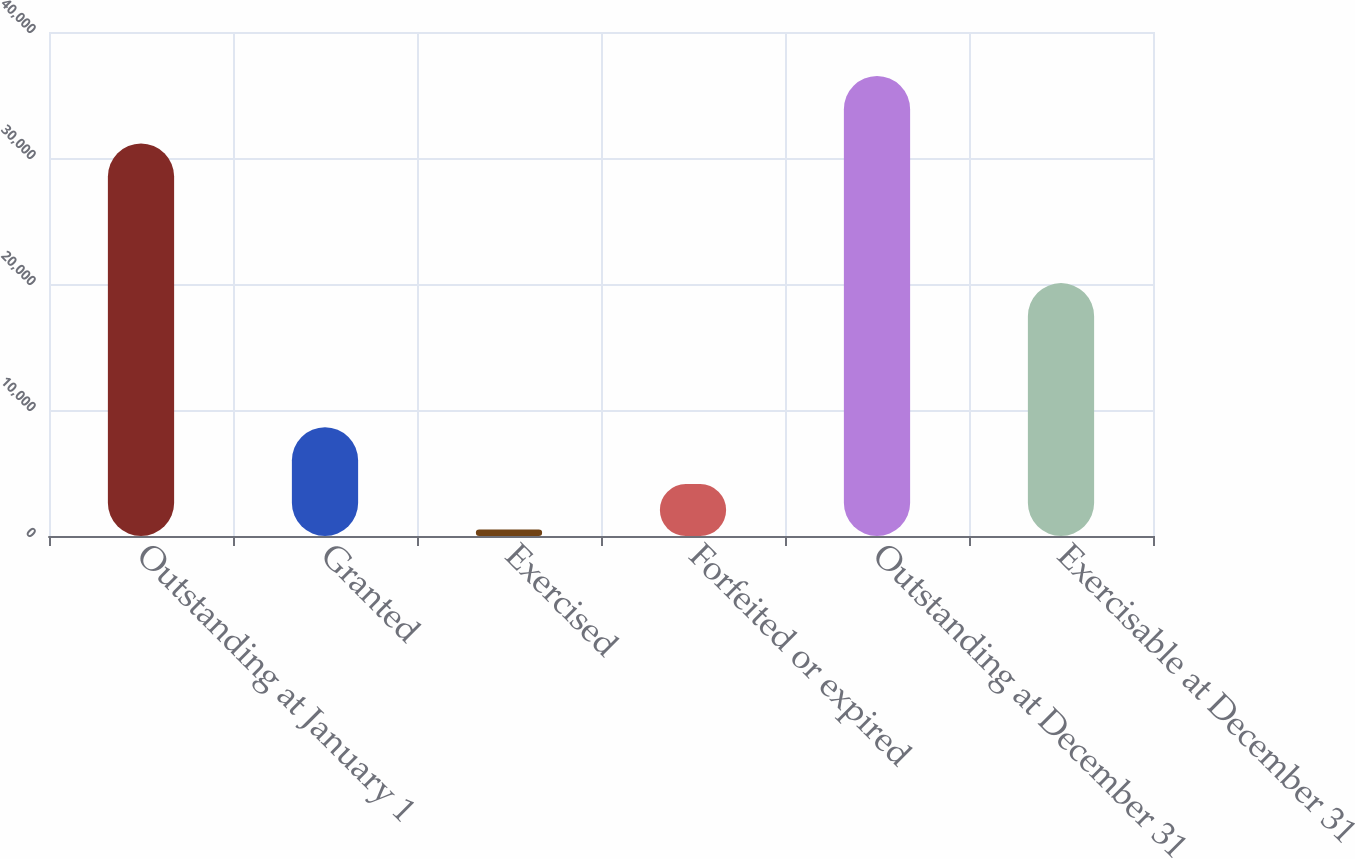Convert chart. <chart><loc_0><loc_0><loc_500><loc_500><bar_chart><fcel>Outstanding at January 1<fcel>Granted<fcel>Exercised<fcel>Forfeited or expired<fcel>Outstanding at December 31<fcel>Exercisable at December 31<nl><fcel>31152<fcel>8633<fcel>521<fcel>4119.1<fcel>36502<fcel>20070<nl></chart> 